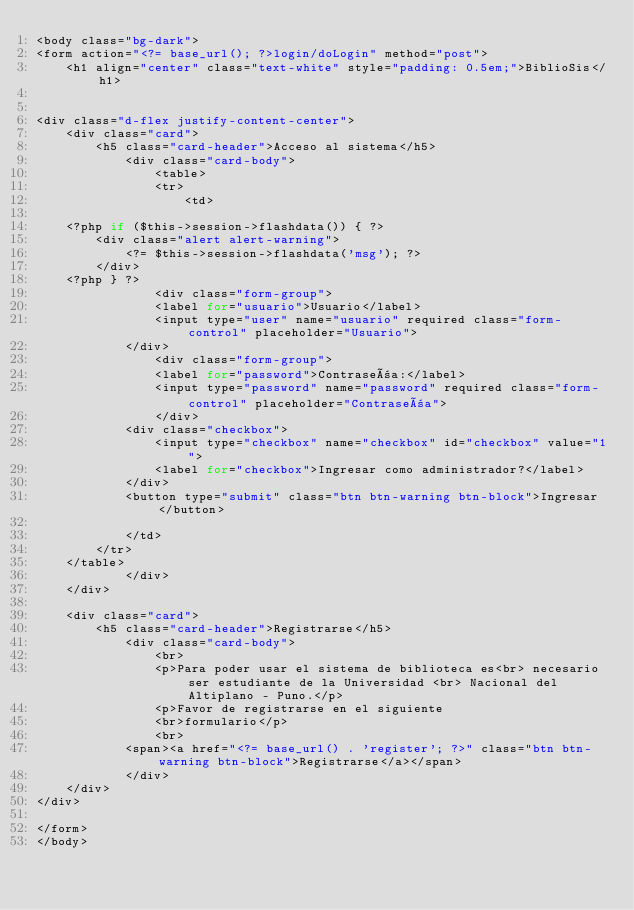Convert code to text. <code><loc_0><loc_0><loc_500><loc_500><_PHP_><body class="bg-dark">
<form action="<?= base_url(); ?>login/doLogin" method="post">
    <h1 align="center" class="text-white" style="padding: 0.5em;">BiblioSis</h1>


<div class="d-flex justify-content-center">
    <div class="card">
        <h5 class="card-header">Acceso al sistema</h5>
            <div class="card-body">
                <table>
                <tr>
                    <td>

    <?php if ($this->session->flashdata()) { ?>
        <div class="alert alert-warning">
            <?= $this->session->flashdata('msg'); ?>
        </div>
    <?php } ?>
                <div class="form-group">
                <label for="usuario">Usuario</label>
                <input type="user" name="usuario" required class="form-control" placeholder="Usuario">
            </div>
                <div class="form-group">
                <label for="password">Contraseña:</label>
                <input type="password" name="password" required class="form-control" placeholder="Contraseña">
                </div>
            <div class="checkbox">
                <input type="checkbox" name="checkbox" id="checkbox" value="1">
                <label for="checkbox">Ingresar como administrador?</label>
            </div>
            <button type="submit" class="btn btn-warning btn-block">Ingresar</button>

            </td>
        </tr>
    </table>
            </div>
    </div>

    <div class="card">
        <h5 class="card-header">Registrarse</h5>
            <div class="card-body">
                <br>
                <p>Para poder usar el sistema de biblioteca es<br> necesario ser estudiante de la Universidad <br> Nacional del Altiplano - Puno.</p>
                <p>Favor de registrarse en el siguiente 
                <br>formulario</p>
                <br>
            <span><a href="<?= base_url() . 'register'; ?>" class="btn btn-warning btn-block">Registrarse</a></span>
            </div>
    </div>
</div>

</form>
</body></code> 